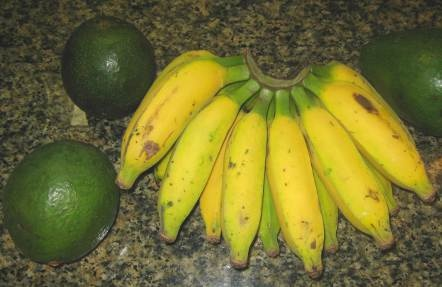Describe the objects in this image and their specific colors. I can see banana in black, gold, and olive tones, orange in black, darkgreen, and olive tones, and orange in black and darkgreen tones in this image. 